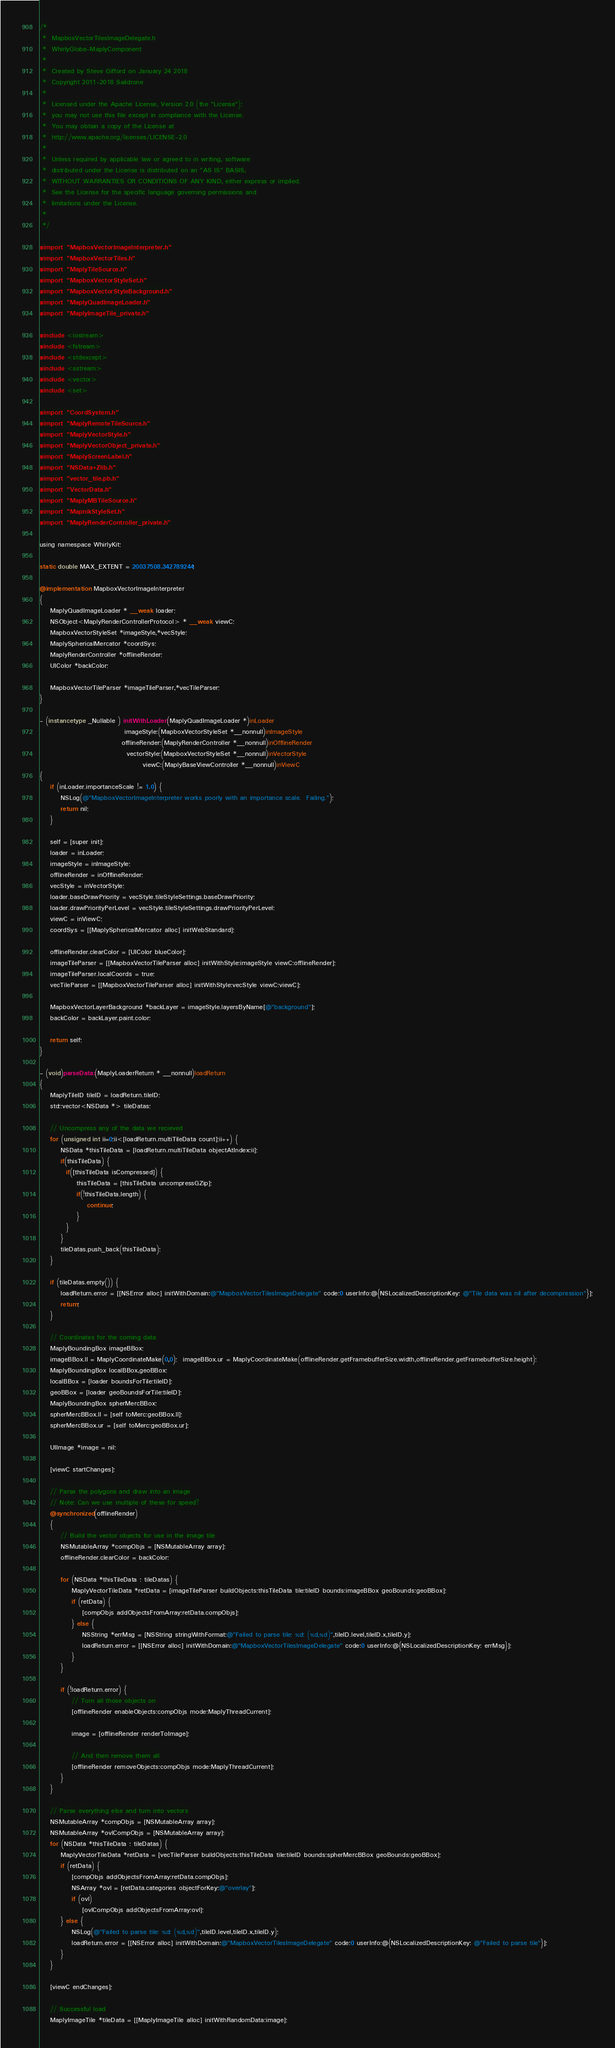<code> <loc_0><loc_0><loc_500><loc_500><_ObjectiveC_>/*
 *  MapboxVectorTilesImageDelegate.h
 *  WhirlyGlobe-MaplyComponent
 *
 *  Created by Steve Gifford on January 24 2018
 *  Copyright 2011-2018 Saildrone
 *
 *  Licensed under the Apache License, Version 2.0 (the "License");
 *  you may not use this file except in compliance with the License.
 *  You may obtain a copy of the License at
 *  http://www.apache.org/licenses/LICENSE-2.0
 *
 *  Unless required by applicable law or agreed to in writing, software
 *  distributed under the License is distributed on an "AS IS" BASIS,
 *  WITHOUT WARRANTIES OR CONDITIONS OF ANY KIND, either express or implied.
 *  See the License for the specific language governing permissions and
 *  limitations under the License.
 *
 */

#import "MapboxVectorImageInterpreter.h"
#import "MapboxVectorTiles.h"
#import "MaplyTileSource.h"
#import "MapboxVectorStyleSet.h"
#import "MapboxVectorStyleBackground.h"
#import "MaplyQuadImageLoader.h"
#import "MaplyImageTile_private.h"

#include <iostream>
#include <fstream>
#include <stdexcept>
#include <sstream>
#include <vector>
#include <set>

#import "CoordSystem.h"
#import "MaplyRemoteTileSource.h"
#import "MaplyVectorStyle.h"
#import "MaplyVectorObject_private.h"
#import "MaplyScreenLabel.h"
#import "NSData+Zlib.h"
#import "vector_tile.pb.h"
#import "VectorData.h"
#import "MaplyMBTileSource.h"
#import "MapnikStyleSet.h"
#import "MaplyRenderController_private.h"

using namespace WhirlyKit;

static double MAX_EXTENT = 20037508.342789244;

@implementation MapboxVectorImageInterpreter
{
    MaplyQuadImageLoader * __weak loader;
    NSObject<MaplyRenderControllerProtocol> * __weak viewC;
    MapboxVectorStyleSet *imageStyle,*vecStyle;
    MaplySphericalMercator *coordSys;
    MaplyRenderController *offlineRender;
    UIColor *backColor;
    
    MapboxVectorTileParser *imageTileParser,*vecTileParser;
}

- (instancetype _Nullable ) initWithLoader:(MaplyQuadImageLoader *)inLoader
                                imageStyle:(MapboxVectorStyleSet *__nonnull)inImageStyle
                               offlineRender:(MaplyRenderController *__nonnull)inOfflineRender
                                 vectorStyle:(MapboxVectorStyleSet *__nonnull)inVectorStyle
                                       viewC:(MaplyBaseViewController *__nonnull)inViewC
{
    if (inLoader.importanceScale != 1.0) {
        NSLog(@"MapboxVectorImageInterpreter works poorly with an importance scale.  Failing.");
        return nil;
    }

    self = [super init];
    loader = inLoader;
    imageStyle = inImageStyle;
    offlineRender = inOfflineRender;
    vecStyle = inVectorStyle;
    loader.baseDrawPriority = vecStyle.tileStyleSettings.baseDrawPriority;
    loader.drawPriorityPerLevel = vecStyle.tileStyleSettings.drawPriorityPerLevel;
    viewC = inViewC;
    coordSys = [[MaplySphericalMercator alloc] initWebStandard];

    offlineRender.clearColor = [UIColor blueColor];
    imageTileParser = [[MapboxVectorTileParser alloc] initWithStyle:imageStyle viewC:offlineRender];
    imageTileParser.localCoords = true;
    vecTileParser = [[MapboxVectorTileParser alloc] initWithStyle:vecStyle viewC:viewC];

    MapboxVectorLayerBackground *backLayer = imageStyle.layersByName[@"background"];
    backColor = backLayer.paint.color;
    
    return self;
}

- (void)parseData:(MaplyLoaderReturn * __nonnull)loadReturn
{
    MaplyTileID tileID = loadReturn.tileID;
    std::vector<NSData *> tileDatas;
    
    // Uncompress any of the data we recieved
    for (unsigned int ii=0;ii<[loadReturn.multiTileData count];ii++) {
        NSData *thisTileData = [loadReturn.multiTileData objectAtIndex:ii];
        if(thisTileData) {
          if([thisTileData isCompressed]) {
              thisTileData = [thisTileData uncompressGZip];
              if(!thisTileData.length) {
                  continue;
              }
          }
        }
        tileDatas.push_back(thisTileData);
    }
    
    if (tileDatas.empty()) {
        loadReturn.error = [[NSError alloc] initWithDomain:@"MapboxVectorTilesImageDelegate" code:0 userInfo:@{NSLocalizedDescriptionKey: @"Tile data was nil after decompression"}];
        return;
    }
    
    // Coordinates for the coming data
    MaplyBoundingBox imageBBox;
    imageBBox.ll = MaplyCoordinateMake(0,0);  imageBBox.ur = MaplyCoordinateMake(offlineRender.getFramebufferSize.width,offlineRender.getFramebufferSize.height);
    MaplyBoundingBox localBBox,geoBBox;
    localBBox = [loader boundsForTile:tileID];
    geoBBox = [loader geoBoundsForTile:tileID];
    MaplyBoundingBox spherMercBBox;
    spherMercBBox.ll = [self toMerc:geoBBox.ll];
    spherMercBBox.ur = [self toMerc:geoBBox.ur];
    
    UIImage *image = nil;
    
    [viewC startChanges];
    
    // Parse the polygons and draw into an image
    // Note: Can we use multiple of these for speed?
    @synchronized(offlineRender)
    {
        // Build the vector objects for use in the image tile
        NSMutableArray *compObjs = [NSMutableArray array];
        offlineRender.clearColor = backColor;

        for (NSData *thisTileData : tileDatas) {
            MaplyVectorTileData *retData = [imageTileParser buildObjects:thisTileData tile:tileID bounds:imageBBox geoBounds:geoBBox];
            if (retData) {
                [compObjs addObjectsFromArray:retData.compObjs];
            } else {
                NSString *errMsg = [NSString stringWithFormat:@"Failed to parse tile: %d: (%d,%d)",tileID.level,tileID.x,tileID.y];
                loadReturn.error = [[NSError alloc] initWithDomain:@"MapboxVectorTilesImageDelegate" code:0 userInfo:@{NSLocalizedDescriptionKey: errMsg}];
            }
        }
        
        if (!loadReturn.error) {
            // Turn all those objects on
            [offlineRender enableObjects:compObjs mode:MaplyThreadCurrent];
            
            image = [offlineRender renderToImage];
            
            // And then remove them all
            [offlineRender removeObjects:compObjs mode:MaplyThreadCurrent];
        }
    }
    
    // Parse everything else and turn into vectors
    NSMutableArray *compObjs = [NSMutableArray array];
    NSMutableArray *ovlCompObjs = [NSMutableArray array];
    for (NSData *thisTileData : tileDatas) {
        MaplyVectorTileData *retData = [vecTileParser buildObjects:thisTileData tile:tileID bounds:spherMercBBox geoBounds:geoBBox];
        if (retData) {
            [compObjs addObjectsFromArray:retData.compObjs];
            NSArray *ovl = [retData.categories objectForKey:@"overlay"];
            if (ovl)
                [ovlCompObjs addObjectsFromArray:ovl];
        } else {
            NSLog(@"Failed to parse tile: %d: (%d,%d)",tileID.level,tileID.x,tileID.y);
            loadReturn.error = [[NSError alloc] initWithDomain:@"MapboxVectorTilesImageDelegate" code:0 userInfo:@{NSLocalizedDescriptionKey: @"Failed to parse tile"}];
        }
    }

    [viewC endChanges];
    
    // Successful load
    MaplyImageTile *tileData = [[MaplyImageTile alloc] initWithRandomData:image];</code> 